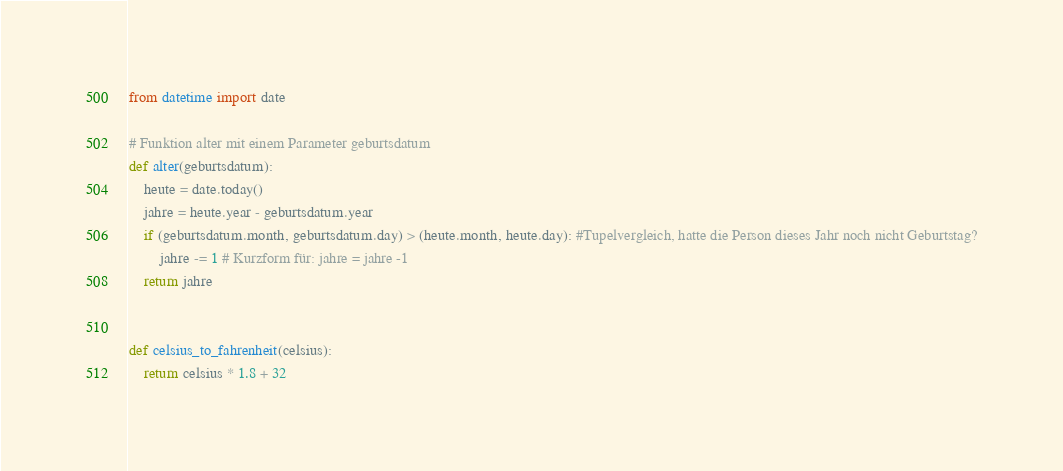Convert code to text. <code><loc_0><loc_0><loc_500><loc_500><_Python_>from datetime import date

# Funktion alter mit einem Parameter geburtsdatum
def alter(geburtsdatum):
    heute = date.today()
    jahre = heute.year - geburtsdatum.year
    if (geburtsdatum.month, geburtsdatum.day) > (heute.month, heute.day): #Tupelvergleich, hatte die Person dieses Jahr noch nicht Geburtstag?
        jahre -= 1 # Kurzform für: jahre = jahre -1
    return jahre


def celsius_to_fahrenheit(celsius):
    return celsius * 1.8 + 32</code> 